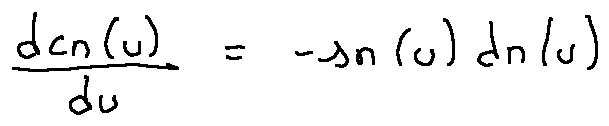<formula> <loc_0><loc_0><loc_500><loc_500>\frac { d c n ( u ) } { d u } = - s n ( u ) d n ( u )</formula> 